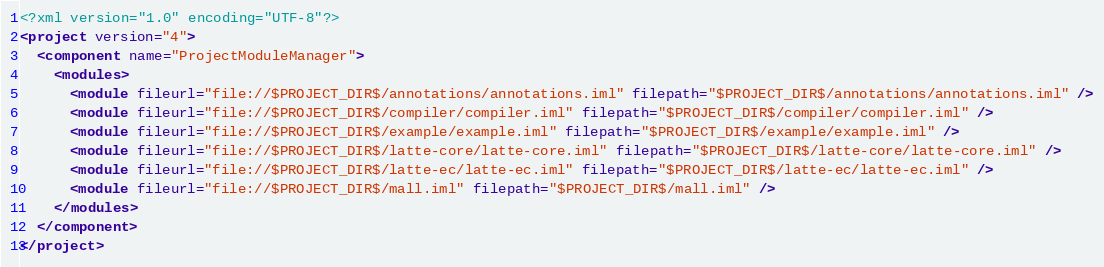Convert code to text. <code><loc_0><loc_0><loc_500><loc_500><_XML_><?xml version="1.0" encoding="UTF-8"?>
<project version="4">
  <component name="ProjectModuleManager">
    <modules>
      <module fileurl="file://$PROJECT_DIR$/annotations/annotations.iml" filepath="$PROJECT_DIR$/annotations/annotations.iml" />
      <module fileurl="file://$PROJECT_DIR$/compiler/compiler.iml" filepath="$PROJECT_DIR$/compiler/compiler.iml" />
      <module fileurl="file://$PROJECT_DIR$/example/example.iml" filepath="$PROJECT_DIR$/example/example.iml" />
      <module fileurl="file://$PROJECT_DIR$/latte-core/latte-core.iml" filepath="$PROJECT_DIR$/latte-core/latte-core.iml" />
      <module fileurl="file://$PROJECT_DIR$/latte-ec/latte-ec.iml" filepath="$PROJECT_DIR$/latte-ec/latte-ec.iml" />
      <module fileurl="file://$PROJECT_DIR$/mall.iml" filepath="$PROJECT_DIR$/mall.iml" />
    </modules>
  </component>
</project></code> 